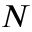Convert formula to latex. <formula><loc_0><loc_0><loc_500><loc_500>N</formula> 